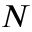Convert formula to latex. <formula><loc_0><loc_0><loc_500><loc_500>N</formula> 